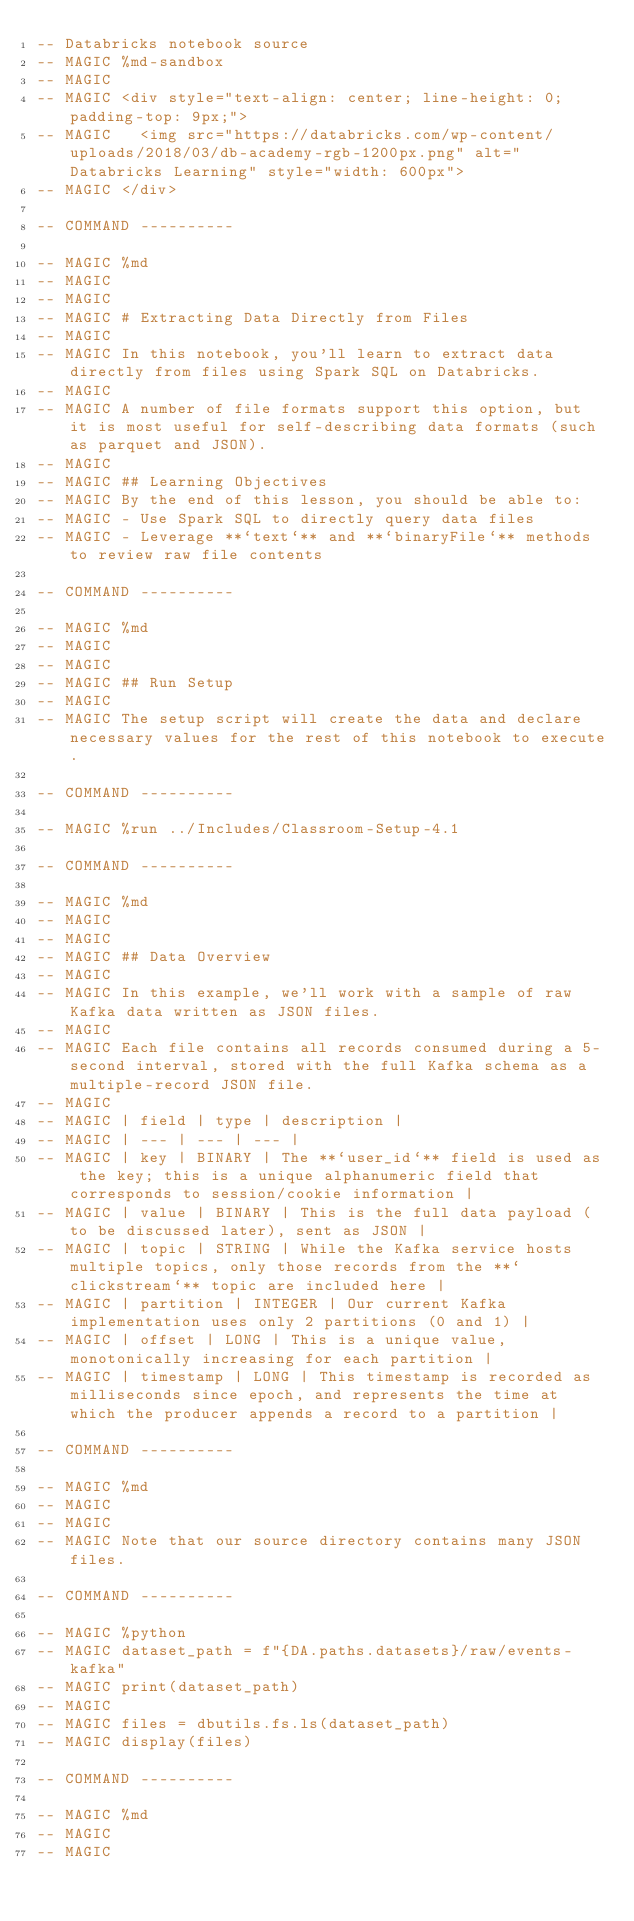<code> <loc_0><loc_0><loc_500><loc_500><_SQL_>-- Databricks notebook source
-- MAGIC %md-sandbox
-- MAGIC 
-- MAGIC <div style="text-align: center; line-height: 0; padding-top: 9px;">
-- MAGIC   <img src="https://databricks.com/wp-content/uploads/2018/03/db-academy-rgb-1200px.png" alt="Databricks Learning" style="width: 600px">
-- MAGIC </div>

-- COMMAND ----------

-- MAGIC %md
-- MAGIC 
-- MAGIC 
-- MAGIC # Extracting Data Directly from Files
-- MAGIC 
-- MAGIC In this notebook, you'll learn to extract data directly from files using Spark SQL on Databricks.
-- MAGIC 
-- MAGIC A number of file formats support this option, but it is most useful for self-describing data formats (such as parquet and JSON).
-- MAGIC 
-- MAGIC ## Learning Objectives
-- MAGIC By the end of this lesson, you should be able to:
-- MAGIC - Use Spark SQL to directly query data files
-- MAGIC - Leverage **`text`** and **`binaryFile`** methods to review raw file contents

-- COMMAND ----------

-- MAGIC %md
-- MAGIC 
-- MAGIC 
-- MAGIC ## Run Setup
-- MAGIC 
-- MAGIC The setup script will create the data and declare necessary values for the rest of this notebook to execute.

-- COMMAND ----------

-- MAGIC %run ../Includes/Classroom-Setup-4.1

-- COMMAND ----------

-- MAGIC %md
-- MAGIC 
-- MAGIC 
-- MAGIC ## Data Overview
-- MAGIC 
-- MAGIC In this example, we'll work with a sample of raw Kafka data written as JSON files. 
-- MAGIC 
-- MAGIC Each file contains all records consumed during a 5-second interval, stored with the full Kafka schema as a multiple-record JSON file.
-- MAGIC 
-- MAGIC | field | type | description |
-- MAGIC | --- | --- | --- |
-- MAGIC | key | BINARY | The **`user_id`** field is used as the key; this is a unique alphanumeric field that corresponds to session/cookie information |
-- MAGIC | value | BINARY | This is the full data payload (to be discussed later), sent as JSON |
-- MAGIC | topic | STRING | While the Kafka service hosts multiple topics, only those records from the **`clickstream`** topic are included here |
-- MAGIC | partition | INTEGER | Our current Kafka implementation uses only 2 partitions (0 and 1) |
-- MAGIC | offset | LONG | This is a unique value, monotonically increasing for each partition |
-- MAGIC | timestamp | LONG | This timestamp is recorded as milliseconds since epoch, and represents the time at which the producer appends a record to a partition |

-- COMMAND ----------

-- MAGIC %md
-- MAGIC 
-- MAGIC 
-- MAGIC Note that our source directory contains many JSON files.

-- COMMAND ----------

-- MAGIC %python
-- MAGIC dataset_path = f"{DA.paths.datasets}/raw/events-kafka"
-- MAGIC print(dataset_path)
-- MAGIC 
-- MAGIC files = dbutils.fs.ls(dataset_path)
-- MAGIC display(files)

-- COMMAND ----------

-- MAGIC %md
-- MAGIC 
-- MAGIC </code> 